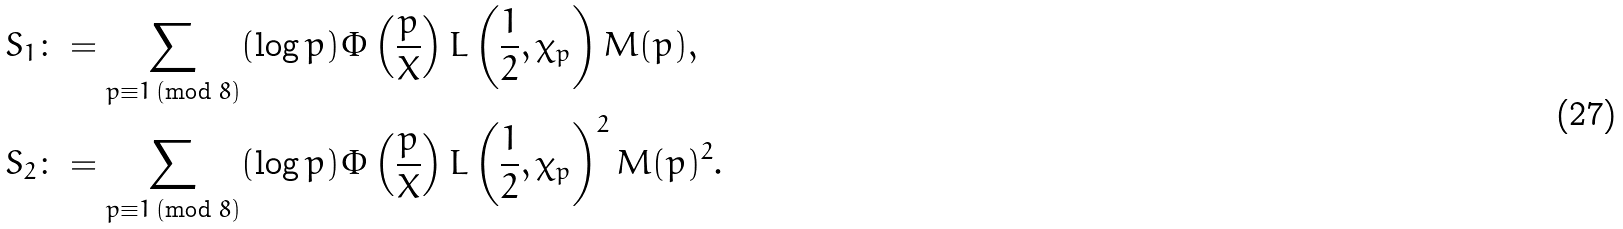<formula> <loc_0><loc_0><loc_500><loc_500>S _ { 1 } & \colon = \sum _ { \substack { p \equiv 1 \, ( \text {mod } 8 ) } } ( \log p ) \Phi \left ( \frac { p } { X } \right ) L \left ( \frac { 1 } { 2 } , \chi _ { p } \right ) M ( p ) , \\ S _ { 2 } & \colon = \sum _ { \substack { p \equiv 1 \, ( \text {mod } 8 ) } } ( \log p ) \Phi \left ( \frac { p } { X } \right ) L \left ( \frac { 1 } { 2 } , \chi _ { p } \right ) ^ { 2 } M ( p ) ^ { 2 } .</formula> 